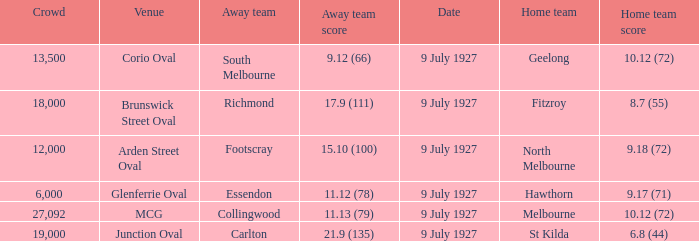Who was the away team playing the home team North Melbourne? Footscray. 